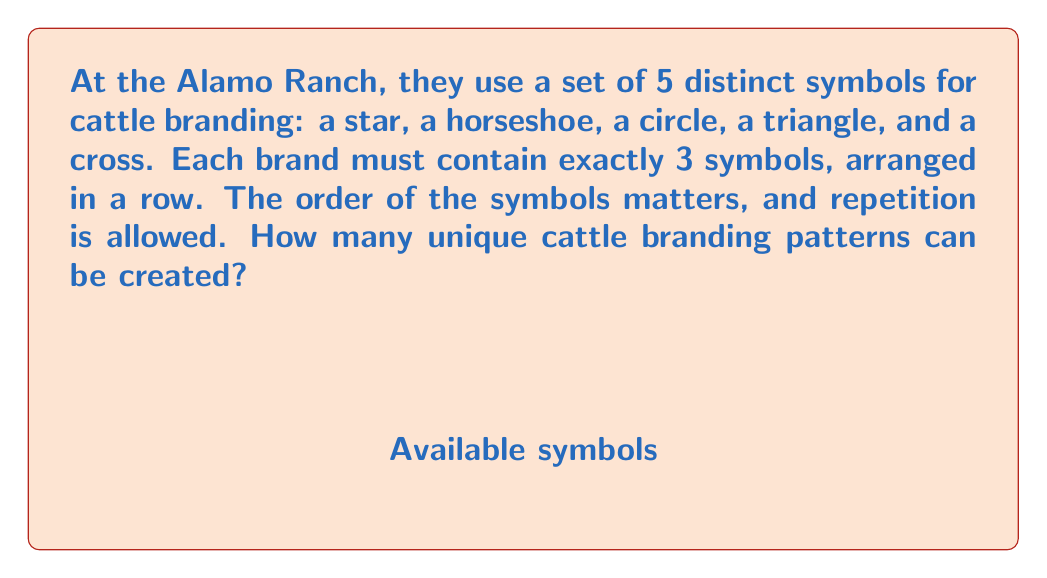Give your solution to this math problem. Let's approach this step-by-step:

1) We need to use the multiplication principle of counting, as we're making a sequence of choices.

2) For each position in the brand (first, second, and third), we have 5 choices of symbols.

3) The choices for each position are independent, meaning the choice for one position doesn't affect the choices for the other positions.

4) Repetition is allowed, so we can use the same symbol multiple times if desired.

5) The order matters, which means "star-horseshoe-circle" is different from "circle-horseshoe-star".

6) Given these conditions, we can calculate the total number of possible arrangements as follows:

   $$ \text{Total arrangements} = 5 \times 5 \times 5 = 5^3 $$

   This is because:
   - We have 5 choices for the first position
   - 5 choices for the second position
   - 5 choices for the third position

7) We can also write this using exponent notation:

   $$ \text{Total arrangements} = 5^3 = 125 $$

Therefore, there are 125 unique cattle branding patterns that can be created using these rules.
Answer: $5^3 = 125$ unique patterns 